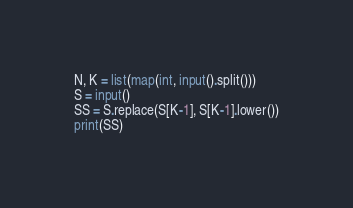<code> <loc_0><loc_0><loc_500><loc_500><_Python_>N, K = list(map(int, input().split()))
S = input()
SS = S.replace(S[K-1], S[K-1].lower())
print(SS)</code> 